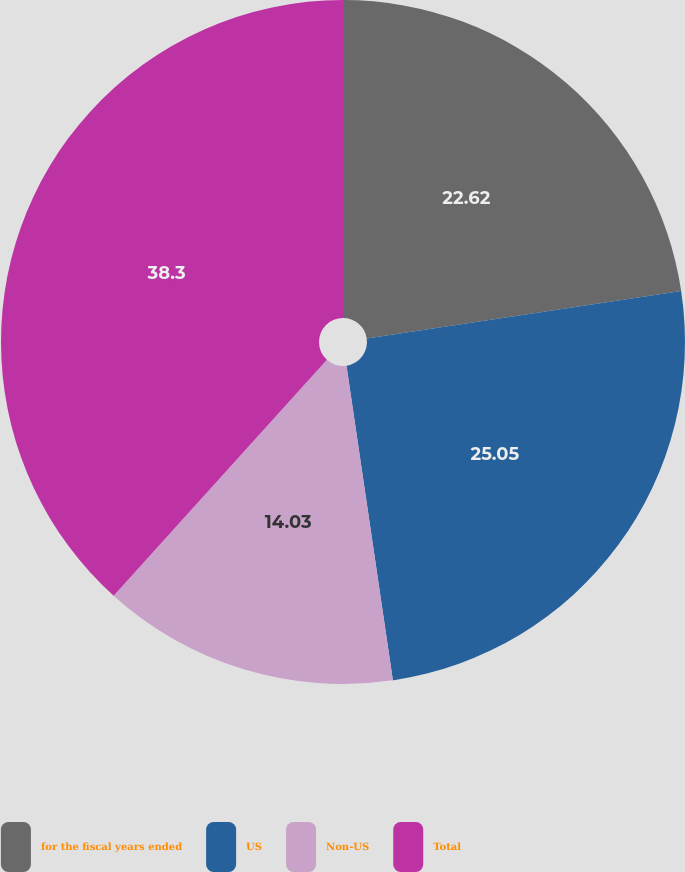Convert chart. <chart><loc_0><loc_0><loc_500><loc_500><pie_chart><fcel>for the fiscal years ended<fcel>US<fcel>Non-US<fcel>Total<nl><fcel>22.62%<fcel>25.05%<fcel>14.03%<fcel>38.3%<nl></chart> 